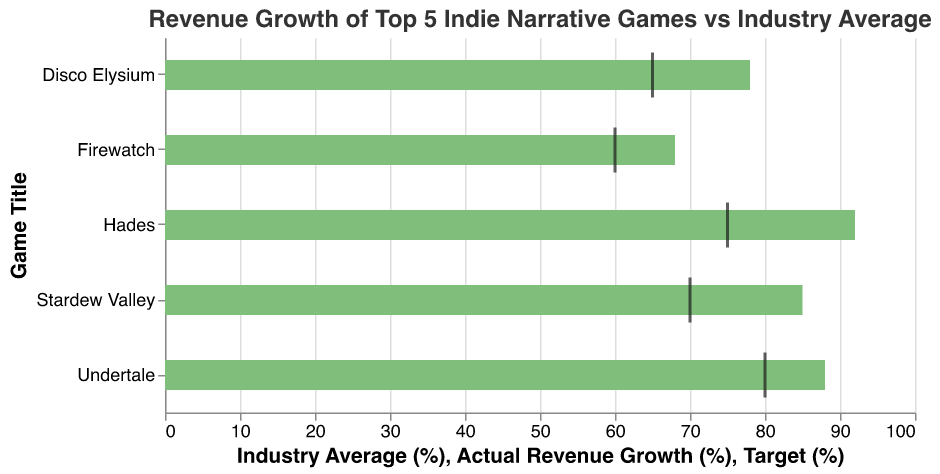How many games exceeded their revenue growth targets? By looking at the tick marks representing the target revenue growth and seeing if the actual revenue growth bars surpass them, we can count how many games met or exceeded their targets. Four games (Stardew Valley, Hades, Disco Elysium, and Undertale) had actual growth higher than their targets.
Answer: Four Which game had the highest actual revenue growth? By comparing the lengths of the green bars representing actual revenue growth, we see that Hades has the highest bar at 92%.
Answer: Hades What is the common industry average revenue growth percentage? The background bars which represent the industry average revenue growth all have the same length, thus we can look at any one of them to see the industry average which is 30%.
Answer: 30% How much higher is Stardew Valley’s actual revenue growth compared to Firewatch? Stardew Valley has an actual growth of 85%, and Firewatch has 68%. The difference between them is 85% - 68% = 17%.
Answer: 17% Which game came closest to meeting its target without exceeding it? By comparing the tick marks (targets) and the green bars (actuals), Firewatch had an actual growth of 68%, very close to its target of 60%, but no game exactly met the target without exceeding it.
Answer: None What is the total combined target growth percentage for all games? Adding up the target percentages for all games: 70% (Stardew Valley) + 75% (Hades) + 65% (Disco Elysium) + 60% (Firewatch) + 80% (Undertale) = 350%.
Answer: 350% Which game's actual revenue growth most significantly exceeded the industry average? By looking at the highest difference between the actual revenue growth and industry average, Hades (92% - 30% = 62%) exceeded the industry average by the highest margin.
Answer: Hades What was the average actual revenue growth among the top 5 games? The actual growth rates are 85%, 92%, 78%, 68%, and 88%. Adding them up and dividing by 5: (85 + 92 + 78 + 68 + 88) / 5 = 82.2%.
Answer: 82.2% 